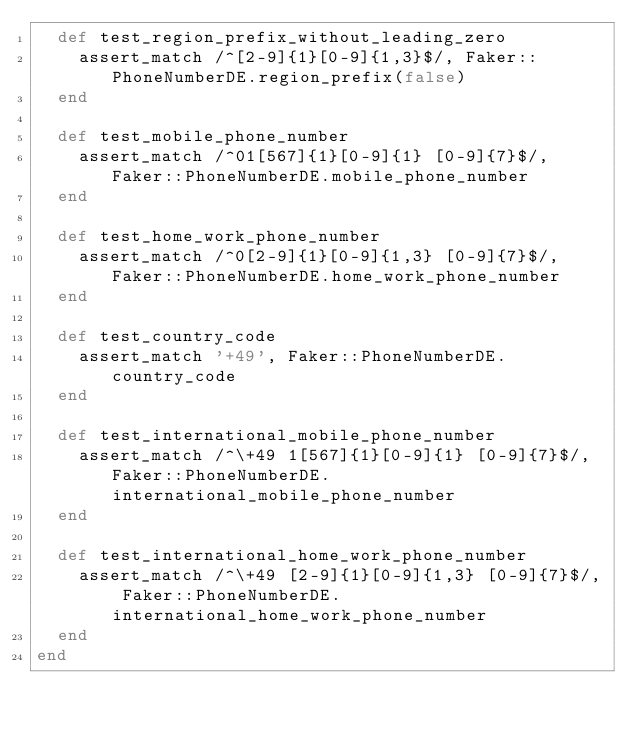<code> <loc_0><loc_0><loc_500><loc_500><_Ruby_>  def test_region_prefix_without_leading_zero
    assert_match /^[2-9]{1}[0-9]{1,3}$/, Faker::PhoneNumberDE.region_prefix(false)
  end

  def test_mobile_phone_number
    assert_match /^01[567]{1}[0-9]{1} [0-9]{7}$/, Faker::PhoneNumberDE.mobile_phone_number
  end

  def test_home_work_phone_number
    assert_match /^0[2-9]{1}[0-9]{1,3} [0-9]{7}$/, Faker::PhoneNumberDE.home_work_phone_number
  end

  def test_country_code
    assert_match '+49', Faker::PhoneNumberDE.country_code
  end

  def test_international_mobile_phone_number
    assert_match /^\+49 1[567]{1}[0-9]{1} [0-9]{7}$/, Faker::PhoneNumberDE.international_mobile_phone_number
  end

  def test_international_home_work_phone_number
    assert_match /^\+49 [2-9]{1}[0-9]{1,3} [0-9]{7}$/, Faker::PhoneNumberDE.international_home_work_phone_number
  end
end
</code> 